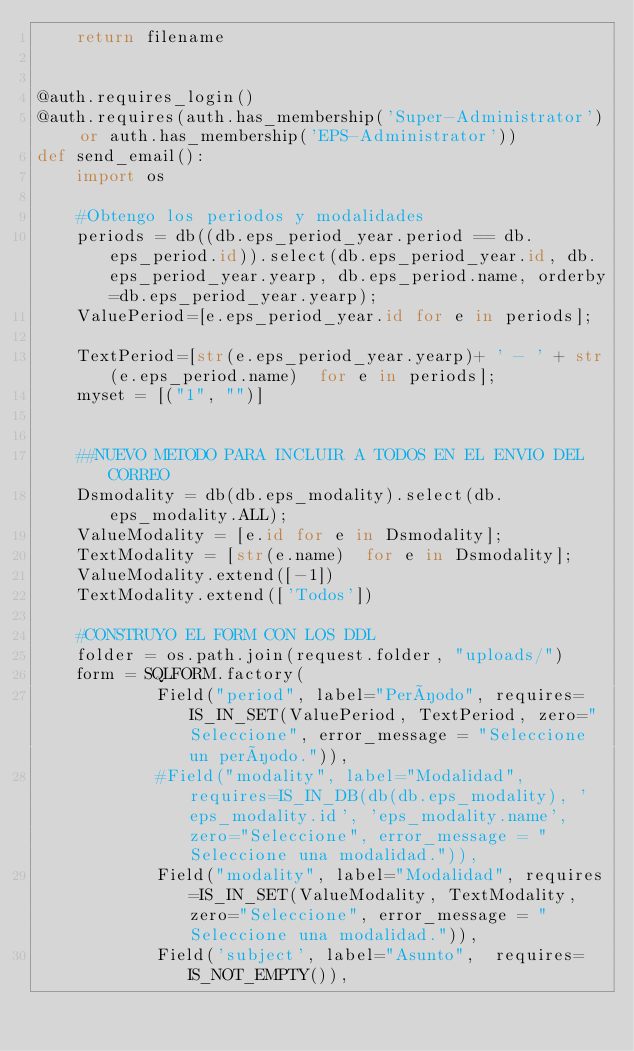<code> <loc_0><loc_0><loc_500><loc_500><_Python_>    return filename


@auth.requires_login()
@auth.requires(auth.has_membership('Super-Administrator') or auth.has_membership('EPS-Administrator'))
def send_email():
    import os

    #Obtengo los periodos y modalidades
    periods = db((db.eps_period_year.period == db.eps_period.id)).select(db.eps_period_year.id, db.eps_period_year.yearp, db.eps_period.name, orderby=db.eps_period_year.yearp);
    ValuePeriod=[e.eps_period_year.id for e in periods];

    TextPeriod=[str(e.eps_period_year.yearp)+ ' - ' + str(e.eps_period.name)  for e in periods];
    myset = [("1", "")]

    
    ##NUEVO METODO PARA INCLUIR A TODOS EN EL ENVIO DEL CORREO
    Dsmodality = db(db.eps_modality).select(db.eps_modality.ALL);
    ValueModality = [e.id for e in Dsmodality];
    TextModality = [str(e.name)  for e in Dsmodality];
    ValueModality.extend([-1])
    TextModality.extend(['Todos'])
    
    #CONSTRUYO EL FORM CON LOS DDL
    folder = os.path.join(request.folder, "uploads/")
    form = SQLFORM.factory(
            Field("period", label="Período", requires=IS_IN_SET(ValuePeriod, TextPeriod, zero="Seleccione", error_message = "Seleccione un período.")),
            #Field("modality", label="Modalidad", requires=IS_IN_DB(db(db.eps_modality), 'eps_modality.id', 'eps_modality.name', zero="Seleccione", error_message = "Seleccione una modalidad.")),
            Field("modality", label="Modalidad", requires=IS_IN_SET(ValueModality, TextModality, zero="Seleccione", error_message = "Seleccione una modalidad.")),
            Field('subject', label="Asunto",  requires=IS_NOT_EMPTY()),</code> 